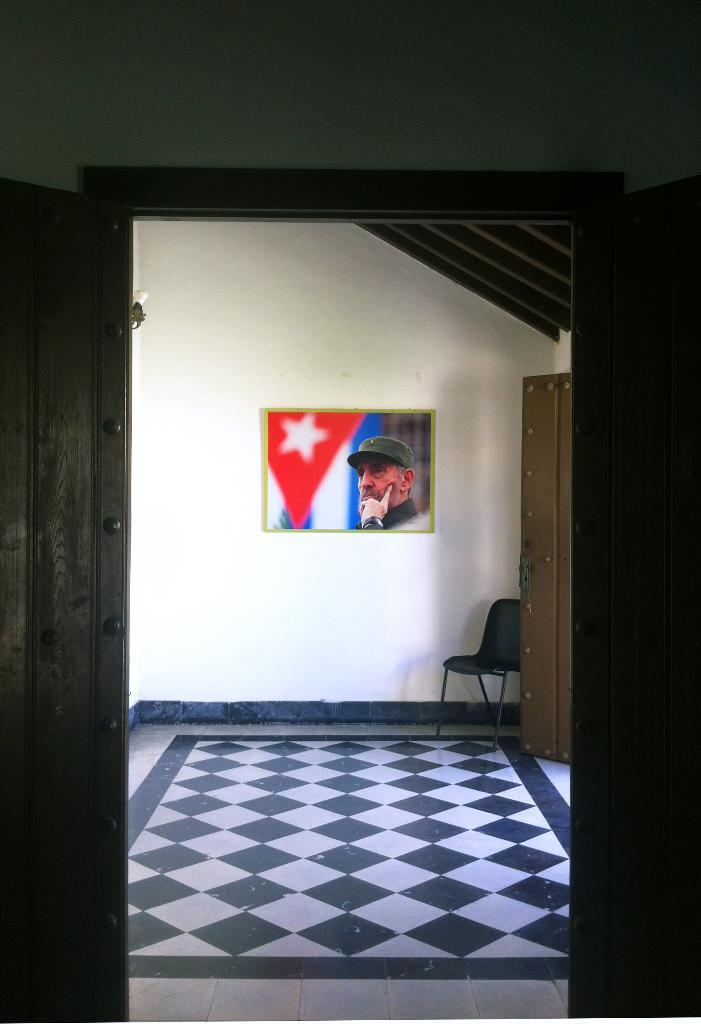What is the main subject in the middle of the scene? There is an image in the middle of the scene. What type of furniture is on the right side of the scene? There is a chair on the right side of the scene. What can be found at the bottom of the scene? Stones are present at the bottom of the scene. What type of suit is the person wearing in the image? There is no person present in the image, so it is not possible to determine what type of suit they might be wearing. 